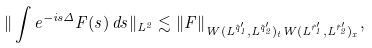<formula> <loc_0><loc_0><loc_500><loc_500>\| \int e ^ { - i s \Delta } F ( s ) \, d s \| _ { L ^ { 2 } } \lesssim \| F \| _ { W ( L ^ { \tilde { q } _ { 1 } ^ { \prime } } , L ^ { \tilde { q } _ { 2 } ^ { \prime } } ) _ { t } W ( L ^ { \tilde { r } _ { 1 } ^ { \prime } } , L ^ { \tilde { r } _ { 2 } ^ { \prime } } ) _ { x } } ,</formula> 